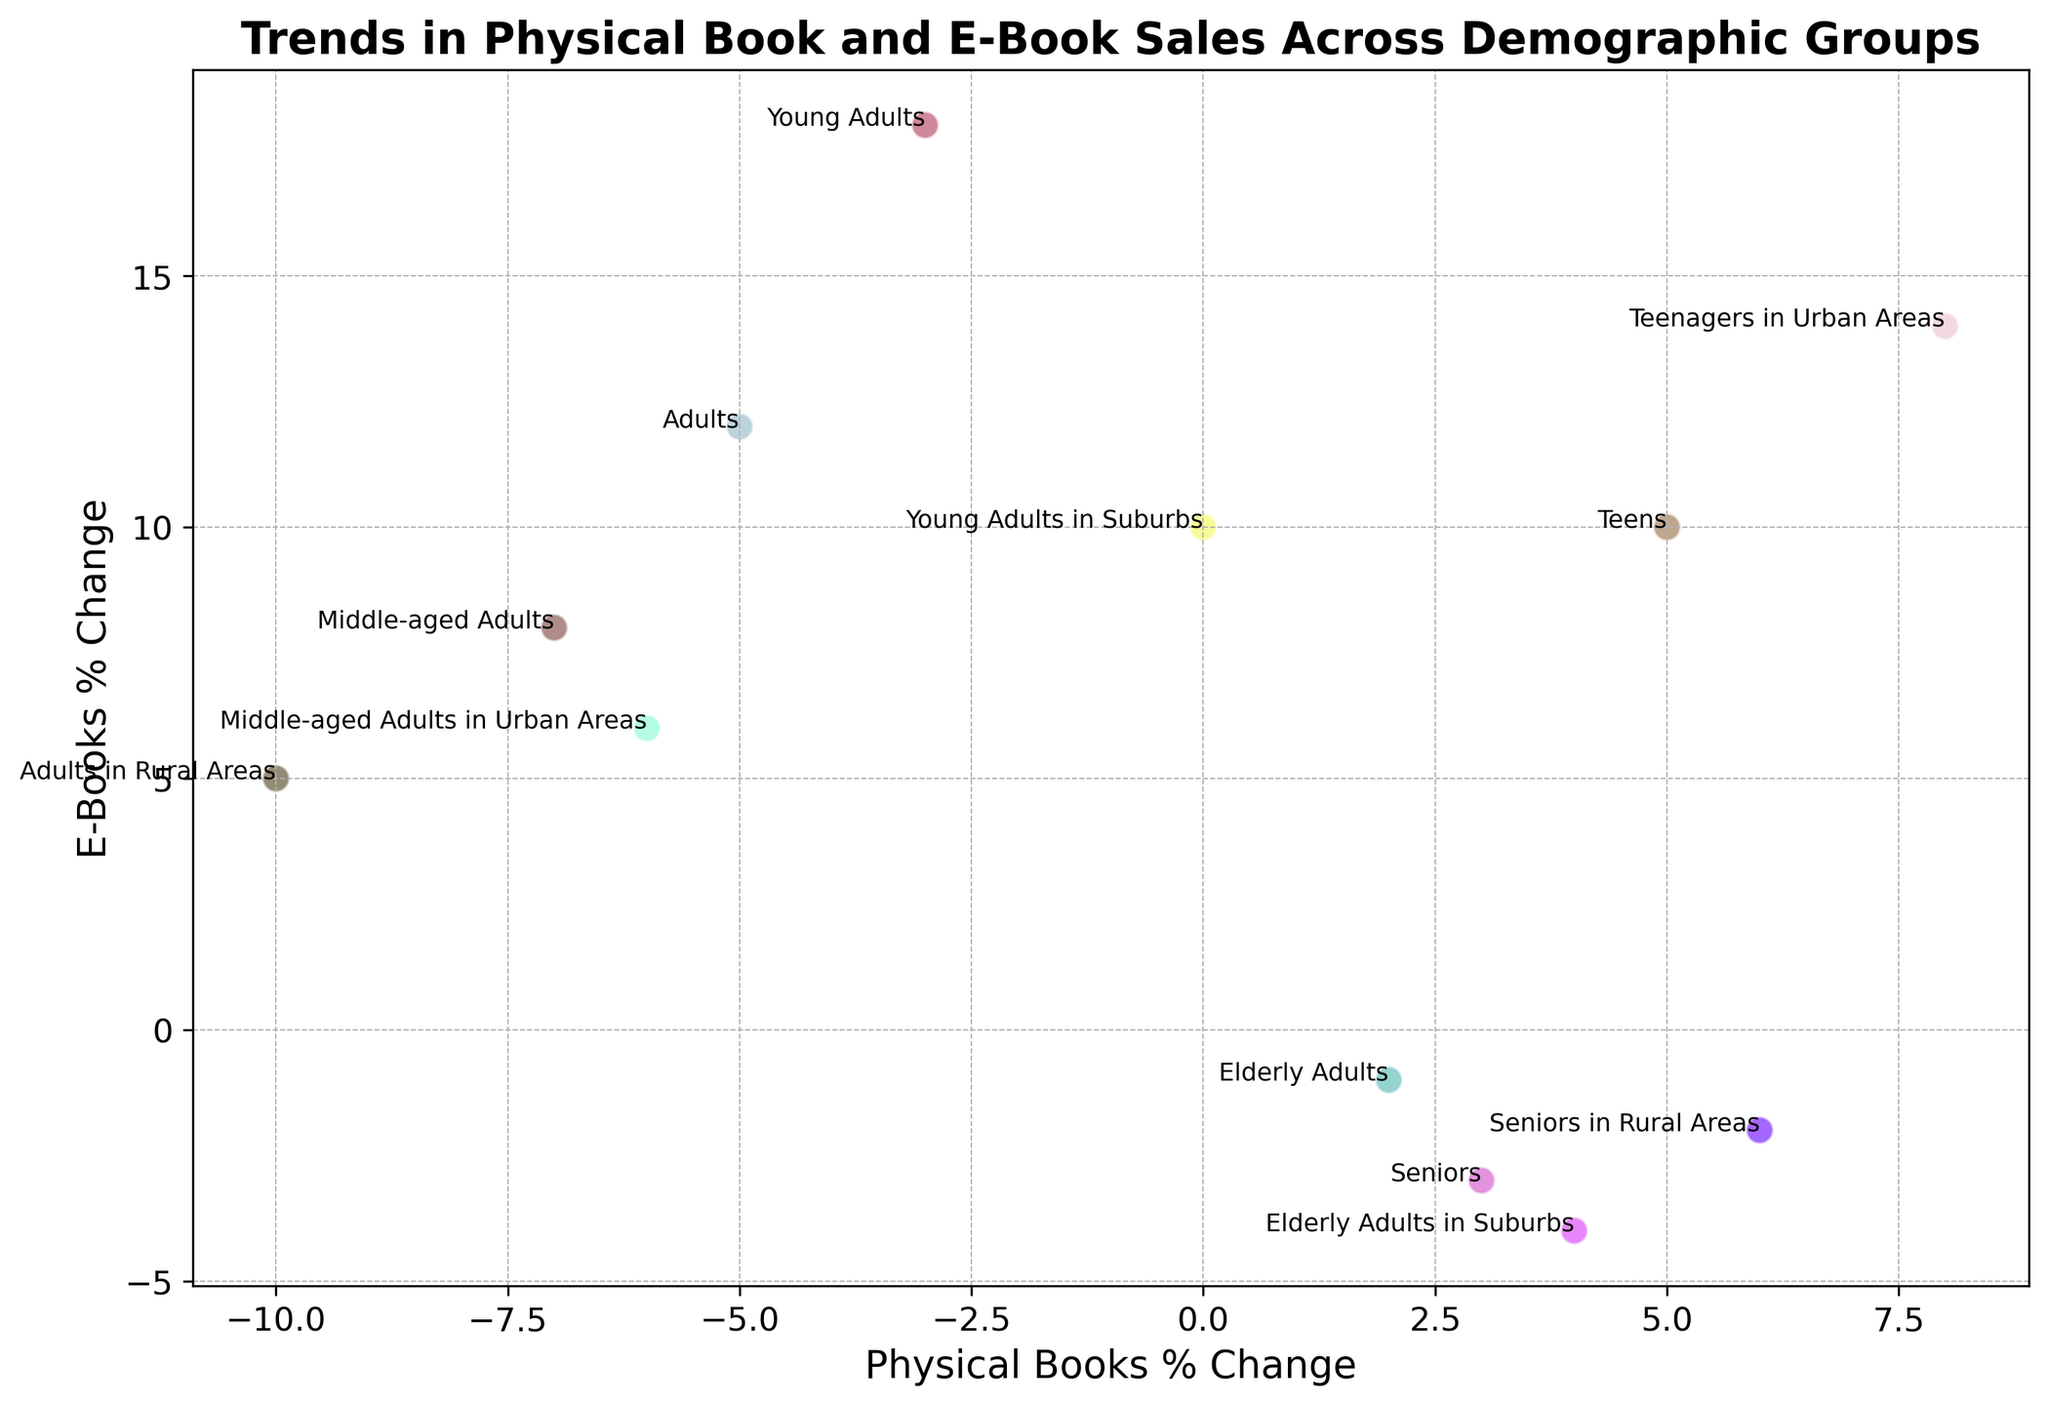What's the overall trend between physical books and e-books sales? The figure shows that most demographic groups have an increase in e-books sales but a decrease in physical book sales. This suggests e-books are becoming more popular than physical books.
Answer: E-books increasing, physical books decreasing Which demographic group has the highest increase in e-book sales? By looking at the vertical axis, Young Adults (20-29) have the highest increase in e-book sales with an 18% change.
Answer: Young Adults Which demographic group has the lowest decrease in physical book sales? By checking the horizontal axis for the smallest negative number, Middle-aged Adults (40-49) have a -7% change, which is the smallest decrease.
Answer: Middle-aged Adults What is the difference in e-books % change between Teens and Adults in Rural Areas? Teens have a 10% change in e-books sales, and Adults in Rural Areas have a 5% change. So, the difference is 10% - 5% = 5%.
Answer: 5% Which demographic group shows an increase in both physical books and e-books sales? By observing the scatter plot, Teenagers in Urban Areas show increases in both physical books (8%) and e-books (14%).
Answer: Teenagers in Urban Areas Compare the change in physical books and e-books sales for Seniors and Elderly Adults. Seniors (60+) have a 3% increase in physical books and a -3% change in e-books, while Elderly Adults (50-59) have a 2% increase in physical books and a -1% change in e-books.
Answer: Seniors vs. Elderly Adults What is the sum of the physical books % change for all groups showing an increase in physical books sales? The groups are Teens (5%), Elderly Adults (2%), Seniors (3%), Teenagers in Urban Areas (8%), Elderly Adults in Suburbs (4%), and Seniors in Rural Areas (6%). The sum is 5 + 2 + 3 + 8 + 4 + 6 = 28%.
Answer: 28% What is the average e-books % change for the groups that have a decline in physical book sales? Young Adults (-3%, 18%), Adults (-5%, 12%), Middle-aged Adults (-7%, 8%), Adults in Rural Areas (-10%, 5%), Middle-aged Adults in Urban Areas (-6%, 6%). The average is (18 + 12 + 8 + 5 + 6) / 5 = 9.8%.
Answer: 9.8% Which visual markers represent the demographic group with the lowest decline in e-book sales? By examining the scatter plot, Elderly Adults (50-59) have the lowest decline in e-books sales at -1%. This is represented by the point close to the origin on the negative side of the vertical axis.
Answer: Elderly Adults 